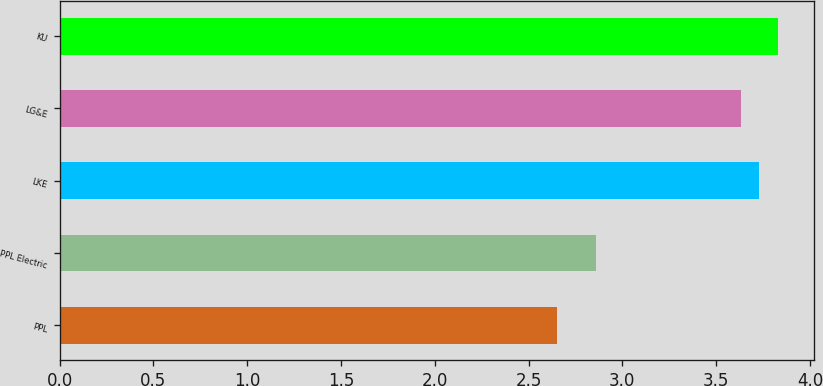Convert chart to OTSL. <chart><loc_0><loc_0><loc_500><loc_500><bar_chart><fcel>PPL<fcel>PPL Electric<fcel>LKE<fcel>LG&E<fcel>KU<nl><fcel>2.65<fcel>2.86<fcel>3.73<fcel>3.63<fcel>3.83<nl></chart> 